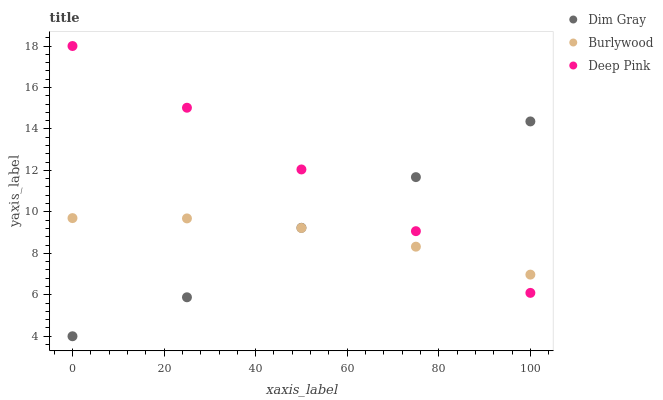Does Burlywood have the minimum area under the curve?
Answer yes or no. Yes. Does Deep Pink have the maximum area under the curve?
Answer yes or no. Yes. Does Dim Gray have the minimum area under the curve?
Answer yes or no. No. Does Dim Gray have the maximum area under the curve?
Answer yes or no. No. Is Deep Pink the smoothest?
Answer yes or no. Yes. Is Dim Gray the roughest?
Answer yes or no. Yes. Is Dim Gray the smoothest?
Answer yes or no. No. Is Deep Pink the roughest?
Answer yes or no. No. Does Dim Gray have the lowest value?
Answer yes or no. Yes. Does Deep Pink have the lowest value?
Answer yes or no. No. Does Deep Pink have the highest value?
Answer yes or no. Yes. Does Dim Gray have the highest value?
Answer yes or no. No. Does Burlywood intersect Dim Gray?
Answer yes or no. Yes. Is Burlywood less than Dim Gray?
Answer yes or no. No. Is Burlywood greater than Dim Gray?
Answer yes or no. No. 